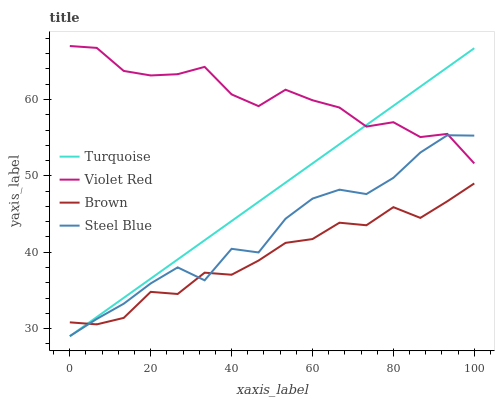Does Brown have the minimum area under the curve?
Answer yes or no. Yes. Does Violet Red have the maximum area under the curve?
Answer yes or no. Yes. Does Turquoise have the minimum area under the curve?
Answer yes or no. No. Does Turquoise have the maximum area under the curve?
Answer yes or no. No. Is Turquoise the smoothest?
Answer yes or no. Yes. Is Violet Red the roughest?
Answer yes or no. Yes. Is Violet Red the smoothest?
Answer yes or no. No. Is Turquoise the roughest?
Answer yes or no. No. Does Turquoise have the lowest value?
Answer yes or no. Yes. Does Violet Red have the lowest value?
Answer yes or no. No. Does Violet Red have the highest value?
Answer yes or no. Yes. Does Turquoise have the highest value?
Answer yes or no. No. Is Brown less than Violet Red?
Answer yes or no. Yes. Is Violet Red greater than Brown?
Answer yes or no. Yes. Does Turquoise intersect Violet Red?
Answer yes or no. Yes. Is Turquoise less than Violet Red?
Answer yes or no. No. Is Turquoise greater than Violet Red?
Answer yes or no. No. Does Brown intersect Violet Red?
Answer yes or no. No. 